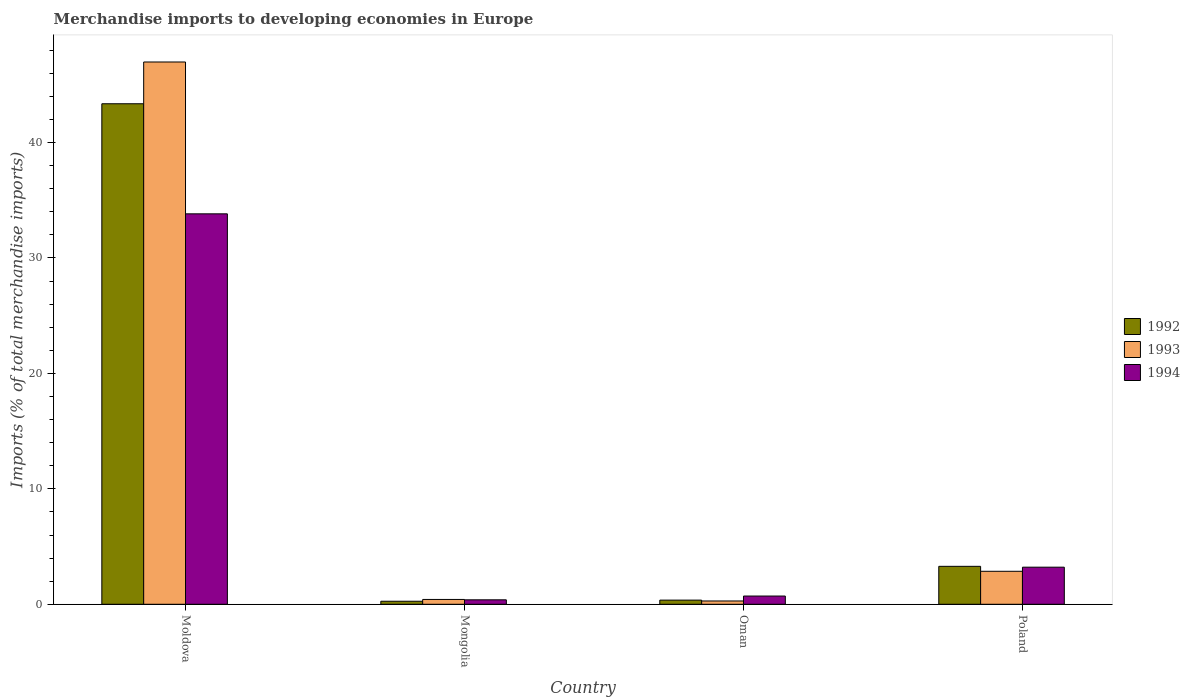How many different coloured bars are there?
Keep it short and to the point. 3. Are the number of bars per tick equal to the number of legend labels?
Make the answer very short. Yes. What is the label of the 4th group of bars from the left?
Give a very brief answer. Poland. What is the percentage total merchandise imports in 1992 in Oman?
Provide a succinct answer. 0.36. Across all countries, what is the maximum percentage total merchandise imports in 1993?
Offer a terse response. 46.98. Across all countries, what is the minimum percentage total merchandise imports in 1993?
Offer a very short reply. 0.29. In which country was the percentage total merchandise imports in 1994 maximum?
Ensure brevity in your answer.  Moldova. In which country was the percentage total merchandise imports in 1992 minimum?
Your response must be concise. Mongolia. What is the total percentage total merchandise imports in 1993 in the graph?
Provide a succinct answer. 50.54. What is the difference between the percentage total merchandise imports in 1992 in Mongolia and that in Oman?
Ensure brevity in your answer.  -0.1. What is the difference between the percentage total merchandise imports in 1993 in Poland and the percentage total merchandise imports in 1992 in Mongolia?
Keep it short and to the point. 2.59. What is the average percentage total merchandise imports in 1993 per country?
Ensure brevity in your answer.  12.64. What is the difference between the percentage total merchandise imports of/in 1992 and percentage total merchandise imports of/in 1994 in Moldova?
Your answer should be very brief. 9.54. What is the ratio of the percentage total merchandise imports in 1992 in Moldova to that in Oman?
Provide a short and direct response. 120.07. Is the percentage total merchandise imports in 1993 in Moldova less than that in Poland?
Your answer should be compact. No. Is the difference between the percentage total merchandise imports in 1992 in Moldova and Oman greater than the difference between the percentage total merchandise imports in 1994 in Moldova and Oman?
Give a very brief answer. Yes. What is the difference between the highest and the second highest percentage total merchandise imports in 1993?
Your response must be concise. -2.44. What is the difference between the highest and the lowest percentage total merchandise imports in 1992?
Your answer should be very brief. 43.1. What does the 3rd bar from the right in Moldova represents?
Your answer should be very brief. 1992. How many bars are there?
Provide a short and direct response. 12. Are all the bars in the graph horizontal?
Make the answer very short. No. How many countries are there in the graph?
Offer a terse response. 4. Does the graph contain any zero values?
Provide a succinct answer. No. Does the graph contain grids?
Your answer should be very brief. No. What is the title of the graph?
Your answer should be compact. Merchandise imports to developing economies in Europe. What is the label or title of the Y-axis?
Your response must be concise. Imports (% of total merchandise imports). What is the Imports (% of total merchandise imports) in 1992 in Moldova?
Offer a very short reply. 43.36. What is the Imports (% of total merchandise imports) in 1993 in Moldova?
Provide a short and direct response. 46.98. What is the Imports (% of total merchandise imports) in 1994 in Moldova?
Your answer should be very brief. 33.82. What is the Imports (% of total merchandise imports) in 1992 in Mongolia?
Make the answer very short. 0.26. What is the Imports (% of total merchandise imports) of 1993 in Mongolia?
Offer a very short reply. 0.42. What is the Imports (% of total merchandise imports) of 1994 in Mongolia?
Your answer should be very brief. 0.39. What is the Imports (% of total merchandise imports) in 1992 in Oman?
Your answer should be compact. 0.36. What is the Imports (% of total merchandise imports) in 1993 in Oman?
Your answer should be very brief. 0.29. What is the Imports (% of total merchandise imports) in 1994 in Oman?
Ensure brevity in your answer.  0.71. What is the Imports (% of total merchandise imports) in 1992 in Poland?
Give a very brief answer. 3.29. What is the Imports (% of total merchandise imports) of 1993 in Poland?
Offer a terse response. 2.86. What is the Imports (% of total merchandise imports) in 1994 in Poland?
Provide a short and direct response. 3.21. Across all countries, what is the maximum Imports (% of total merchandise imports) in 1992?
Your answer should be compact. 43.36. Across all countries, what is the maximum Imports (% of total merchandise imports) in 1993?
Keep it short and to the point. 46.98. Across all countries, what is the maximum Imports (% of total merchandise imports) in 1994?
Your answer should be very brief. 33.82. Across all countries, what is the minimum Imports (% of total merchandise imports) of 1992?
Your answer should be compact. 0.26. Across all countries, what is the minimum Imports (% of total merchandise imports) of 1993?
Offer a terse response. 0.29. Across all countries, what is the minimum Imports (% of total merchandise imports) in 1994?
Your answer should be compact. 0.39. What is the total Imports (% of total merchandise imports) of 1992 in the graph?
Your answer should be compact. 47.27. What is the total Imports (% of total merchandise imports) in 1993 in the graph?
Keep it short and to the point. 50.54. What is the total Imports (% of total merchandise imports) of 1994 in the graph?
Provide a short and direct response. 38.14. What is the difference between the Imports (% of total merchandise imports) in 1992 in Moldova and that in Mongolia?
Your answer should be compact. 43.1. What is the difference between the Imports (% of total merchandise imports) of 1993 in Moldova and that in Mongolia?
Provide a short and direct response. 46.56. What is the difference between the Imports (% of total merchandise imports) of 1994 in Moldova and that in Mongolia?
Your response must be concise. 33.44. What is the difference between the Imports (% of total merchandise imports) in 1992 in Moldova and that in Oman?
Offer a terse response. 43. What is the difference between the Imports (% of total merchandise imports) of 1993 in Moldova and that in Oman?
Keep it short and to the point. 46.69. What is the difference between the Imports (% of total merchandise imports) of 1994 in Moldova and that in Oman?
Keep it short and to the point. 33.11. What is the difference between the Imports (% of total merchandise imports) of 1992 in Moldova and that in Poland?
Give a very brief answer. 40.07. What is the difference between the Imports (% of total merchandise imports) of 1993 in Moldova and that in Poland?
Your answer should be very brief. 44.12. What is the difference between the Imports (% of total merchandise imports) of 1994 in Moldova and that in Poland?
Provide a succinct answer. 30.61. What is the difference between the Imports (% of total merchandise imports) in 1992 in Mongolia and that in Oman?
Offer a terse response. -0.1. What is the difference between the Imports (% of total merchandise imports) in 1993 in Mongolia and that in Oman?
Make the answer very short. 0.13. What is the difference between the Imports (% of total merchandise imports) in 1994 in Mongolia and that in Oman?
Your response must be concise. -0.33. What is the difference between the Imports (% of total merchandise imports) of 1992 in Mongolia and that in Poland?
Your answer should be compact. -3.02. What is the difference between the Imports (% of total merchandise imports) of 1993 in Mongolia and that in Poland?
Give a very brief answer. -2.44. What is the difference between the Imports (% of total merchandise imports) in 1994 in Mongolia and that in Poland?
Keep it short and to the point. -2.83. What is the difference between the Imports (% of total merchandise imports) in 1992 in Oman and that in Poland?
Your answer should be compact. -2.93. What is the difference between the Imports (% of total merchandise imports) in 1993 in Oman and that in Poland?
Provide a short and direct response. -2.57. What is the difference between the Imports (% of total merchandise imports) of 1994 in Oman and that in Poland?
Give a very brief answer. -2.5. What is the difference between the Imports (% of total merchandise imports) of 1992 in Moldova and the Imports (% of total merchandise imports) of 1993 in Mongolia?
Keep it short and to the point. 42.94. What is the difference between the Imports (% of total merchandise imports) of 1992 in Moldova and the Imports (% of total merchandise imports) of 1994 in Mongolia?
Your response must be concise. 42.97. What is the difference between the Imports (% of total merchandise imports) in 1993 in Moldova and the Imports (% of total merchandise imports) in 1994 in Mongolia?
Make the answer very short. 46.59. What is the difference between the Imports (% of total merchandise imports) in 1992 in Moldova and the Imports (% of total merchandise imports) in 1993 in Oman?
Give a very brief answer. 43.07. What is the difference between the Imports (% of total merchandise imports) in 1992 in Moldova and the Imports (% of total merchandise imports) in 1994 in Oman?
Make the answer very short. 42.65. What is the difference between the Imports (% of total merchandise imports) of 1993 in Moldova and the Imports (% of total merchandise imports) of 1994 in Oman?
Your response must be concise. 46.26. What is the difference between the Imports (% of total merchandise imports) of 1992 in Moldova and the Imports (% of total merchandise imports) of 1993 in Poland?
Make the answer very short. 40.5. What is the difference between the Imports (% of total merchandise imports) in 1992 in Moldova and the Imports (% of total merchandise imports) in 1994 in Poland?
Keep it short and to the point. 40.15. What is the difference between the Imports (% of total merchandise imports) of 1993 in Moldova and the Imports (% of total merchandise imports) of 1994 in Poland?
Provide a succinct answer. 43.76. What is the difference between the Imports (% of total merchandise imports) in 1992 in Mongolia and the Imports (% of total merchandise imports) in 1993 in Oman?
Provide a short and direct response. -0.02. What is the difference between the Imports (% of total merchandise imports) in 1992 in Mongolia and the Imports (% of total merchandise imports) in 1994 in Oman?
Your answer should be compact. -0.45. What is the difference between the Imports (% of total merchandise imports) of 1993 in Mongolia and the Imports (% of total merchandise imports) of 1994 in Oman?
Your response must be concise. -0.29. What is the difference between the Imports (% of total merchandise imports) of 1992 in Mongolia and the Imports (% of total merchandise imports) of 1993 in Poland?
Give a very brief answer. -2.59. What is the difference between the Imports (% of total merchandise imports) in 1992 in Mongolia and the Imports (% of total merchandise imports) in 1994 in Poland?
Your response must be concise. -2.95. What is the difference between the Imports (% of total merchandise imports) in 1993 in Mongolia and the Imports (% of total merchandise imports) in 1994 in Poland?
Your answer should be very brief. -2.79. What is the difference between the Imports (% of total merchandise imports) of 1992 in Oman and the Imports (% of total merchandise imports) of 1993 in Poland?
Offer a terse response. -2.5. What is the difference between the Imports (% of total merchandise imports) in 1992 in Oman and the Imports (% of total merchandise imports) in 1994 in Poland?
Provide a short and direct response. -2.85. What is the difference between the Imports (% of total merchandise imports) of 1993 in Oman and the Imports (% of total merchandise imports) of 1994 in Poland?
Keep it short and to the point. -2.93. What is the average Imports (% of total merchandise imports) of 1992 per country?
Keep it short and to the point. 11.82. What is the average Imports (% of total merchandise imports) in 1993 per country?
Offer a very short reply. 12.64. What is the average Imports (% of total merchandise imports) in 1994 per country?
Offer a terse response. 9.53. What is the difference between the Imports (% of total merchandise imports) of 1992 and Imports (% of total merchandise imports) of 1993 in Moldova?
Your answer should be compact. -3.62. What is the difference between the Imports (% of total merchandise imports) of 1992 and Imports (% of total merchandise imports) of 1994 in Moldova?
Keep it short and to the point. 9.54. What is the difference between the Imports (% of total merchandise imports) of 1993 and Imports (% of total merchandise imports) of 1994 in Moldova?
Your answer should be compact. 13.15. What is the difference between the Imports (% of total merchandise imports) in 1992 and Imports (% of total merchandise imports) in 1993 in Mongolia?
Offer a very short reply. -0.16. What is the difference between the Imports (% of total merchandise imports) in 1992 and Imports (% of total merchandise imports) in 1994 in Mongolia?
Make the answer very short. -0.12. What is the difference between the Imports (% of total merchandise imports) in 1993 and Imports (% of total merchandise imports) in 1994 in Mongolia?
Your response must be concise. 0.03. What is the difference between the Imports (% of total merchandise imports) in 1992 and Imports (% of total merchandise imports) in 1993 in Oman?
Offer a very short reply. 0.08. What is the difference between the Imports (% of total merchandise imports) in 1992 and Imports (% of total merchandise imports) in 1994 in Oman?
Keep it short and to the point. -0.35. What is the difference between the Imports (% of total merchandise imports) of 1993 and Imports (% of total merchandise imports) of 1994 in Oman?
Your response must be concise. -0.43. What is the difference between the Imports (% of total merchandise imports) of 1992 and Imports (% of total merchandise imports) of 1993 in Poland?
Make the answer very short. 0.43. What is the difference between the Imports (% of total merchandise imports) of 1992 and Imports (% of total merchandise imports) of 1994 in Poland?
Your answer should be very brief. 0.07. What is the difference between the Imports (% of total merchandise imports) in 1993 and Imports (% of total merchandise imports) in 1994 in Poland?
Keep it short and to the point. -0.36. What is the ratio of the Imports (% of total merchandise imports) of 1992 in Moldova to that in Mongolia?
Keep it short and to the point. 164.88. What is the ratio of the Imports (% of total merchandise imports) of 1993 in Moldova to that in Mongolia?
Provide a succinct answer. 111.98. What is the ratio of the Imports (% of total merchandise imports) in 1994 in Moldova to that in Mongolia?
Make the answer very short. 87.4. What is the ratio of the Imports (% of total merchandise imports) of 1992 in Moldova to that in Oman?
Ensure brevity in your answer.  120.07. What is the ratio of the Imports (% of total merchandise imports) of 1993 in Moldova to that in Oman?
Ensure brevity in your answer.  164.25. What is the ratio of the Imports (% of total merchandise imports) in 1994 in Moldova to that in Oman?
Provide a short and direct response. 47.41. What is the ratio of the Imports (% of total merchandise imports) of 1992 in Moldova to that in Poland?
Your response must be concise. 13.19. What is the ratio of the Imports (% of total merchandise imports) of 1993 in Moldova to that in Poland?
Your answer should be very brief. 16.44. What is the ratio of the Imports (% of total merchandise imports) of 1994 in Moldova to that in Poland?
Your response must be concise. 10.53. What is the ratio of the Imports (% of total merchandise imports) in 1992 in Mongolia to that in Oman?
Give a very brief answer. 0.73. What is the ratio of the Imports (% of total merchandise imports) in 1993 in Mongolia to that in Oman?
Ensure brevity in your answer.  1.47. What is the ratio of the Imports (% of total merchandise imports) of 1994 in Mongolia to that in Oman?
Offer a terse response. 0.54. What is the ratio of the Imports (% of total merchandise imports) in 1993 in Mongolia to that in Poland?
Make the answer very short. 0.15. What is the ratio of the Imports (% of total merchandise imports) in 1994 in Mongolia to that in Poland?
Your answer should be very brief. 0.12. What is the ratio of the Imports (% of total merchandise imports) in 1992 in Oman to that in Poland?
Your answer should be compact. 0.11. What is the ratio of the Imports (% of total merchandise imports) of 1993 in Oman to that in Poland?
Ensure brevity in your answer.  0.1. What is the ratio of the Imports (% of total merchandise imports) of 1994 in Oman to that in Poland?
Keep it short and to the point. 0.22. What is the difference between the highest and the second highest Imports (% of total merchandise imports) of 1992?
Your answer should be very brief. 40.07. What is the difference between the highest and the second highest Imports (% of total merchandise imports) of 1993?
Your response must be concise. 44.12. What is the difference between the highest and the second highest Imports (% of total merchandise imports) in 1994?
Your answer should be very brief. 30.61. What is the difference between the highest and the lowest Imports (% of total merchandise imports) in 1992?
Make the answer very short. 43.1. What is the difference between the highest and the lowest Imports (% of total merchandise imports) of 1993?
Your response must be concise. 46.69. What is the difference between the highest and the lowest Imports (% of total merchandise imports) of 1994?
Ensure brevity in your answer.  33.44. 